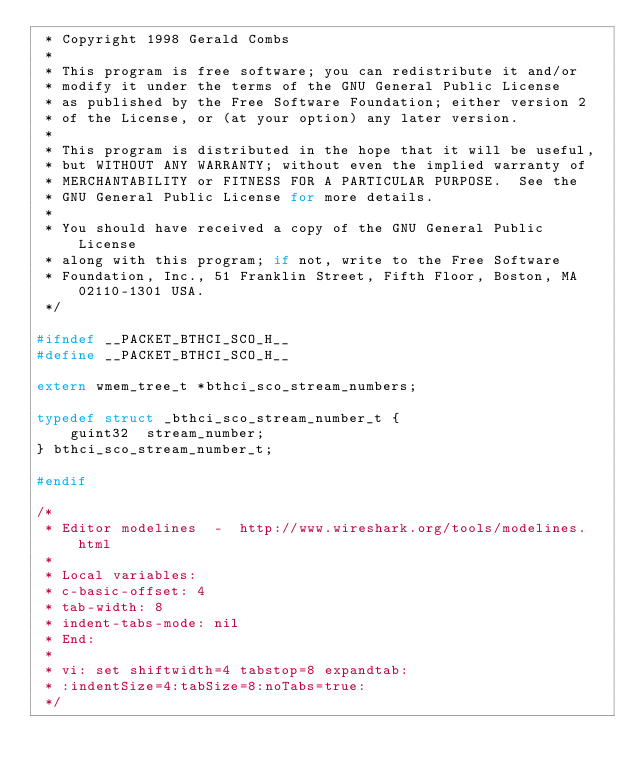Convert code to text. <code><loc_0><loc_0><loc_500><loc_500><_C_> * Copyright 1998 Gerald Combs
 *
 * This program is free software; you can redistribute it and/or
 * modify it under the terms of the GNU General Public License
 * as published by the Free Software Foundation; either version 2
 * of the License, or (at your option) any later version.
 *
 * This program is distributed in the hope that it will be useful,
 * but WITHOUT ANY WARRANTY; without even the implied warranty of
 * MERCHANTABILITY or FITNESS FOR A PARTICULAR PURPOSE.  See the
 * GNU General Public License for more details.
 *
 * You should have received a copy of the GNU General Public License
 * along with this program; if not, write to the Free Software
 * Foundation, Inc., 51 Franklin Street, Fifth Floor, Boston, MA 02110-1301 USA.
 */

#ifndef __PACKET_BTHCI_SCO_H__
#define __PACKET_BTHCI_SCO_H__

extern wmem_tree_t *bthci_sco_stream_numbers;

typedef struct _bthci_sco_stream_number_t {
    guint32  stream_number;
} bthci_sco_stream_number_t;

#endif

/*
 * Editor modelines  -  http://www.wireshark.org/tools/modelines.html
 *
 * Local variables:
 * c-basic-offset: 4
 * tab-width: 8
 * indent-tabs-mode: nil
 * End:
 *
 * vi: set shiftwidth=4 tabstop=8 expandtab:
 * :indentSize=4:tabSize=8:noTabs=true:
 */
</code> 